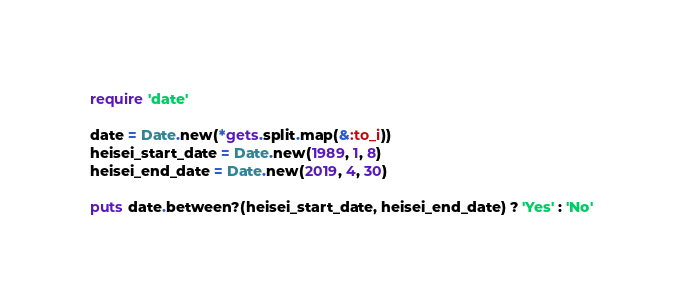<code> <loc_0><loc_0><loc_500><loc_500><_Ruby_>require 'date'

date = Date.new(*gets.split.map(&:to_i))
heisei_start_date = Date.new(1989, 1, 8)
heisei_end_date = Date.new(2019, 4, 30)

puts date.between?(heisei_start_date, heisei_end_date) ? 'Yes' : 'No'</code> 